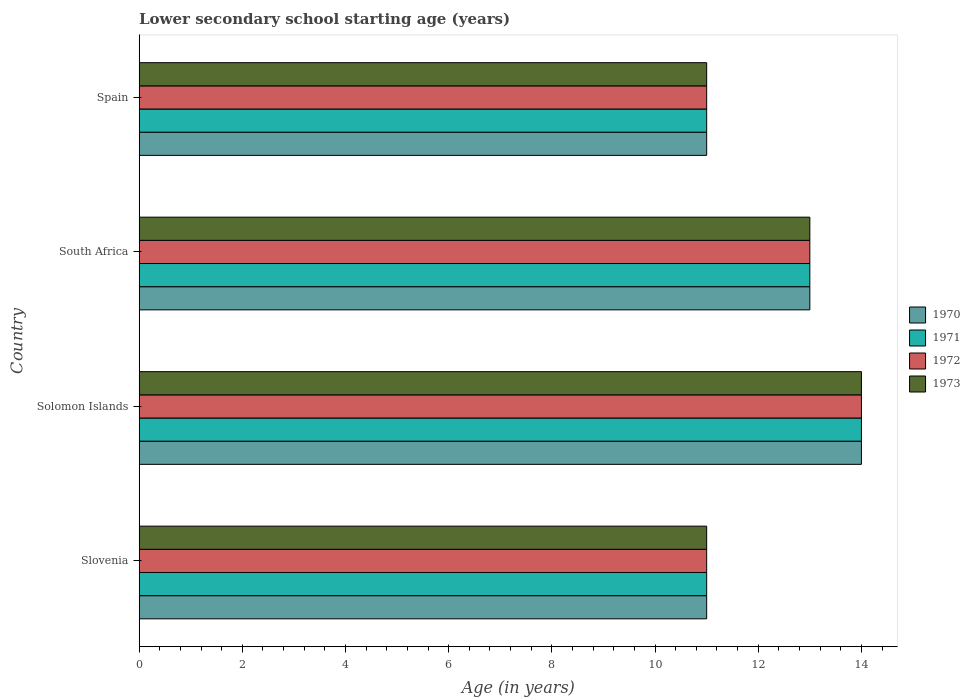How many different coloured bars are there?
Make the answer very short. 4. Are the number of bars per tick equal to the number of legend labels?
Keep it short and to the point. Yes. Are the number of bars on each tick of the Y-axis equal?
Keep it short and to the point. Yes. What is the label of the 1st group of bars from the top?
Give a very brief answer. Spain. What is the lower secondary school starting age of children in 1970 in Solomon Islands?
Provide a succinct answer. 14. Across all countries, what is the minimum lower secondary school starting age of children in 1973?
Make the answer very short. 11. In which country was the lower secondary school starting age of children in 1971 maximum?
Give a very brief answer. Solomon Islands. In which country was the lower secondary school starting age of children in 1973 minimum?
Your response must be concise. Slovenia. What is the total lower secondary school starting age of children in 1973 in the graph?
Offer a very short reply. 49. What is the difference between the lower secondary school starting age of children in 1972 in South Africa and that in Spain?
Ensure brevity in your answer.  2. What is the difference between the lower secondary school starting age of children in 1971 in Solomon Islands and the lower secondary school starting age of children in 1972 in Spain?
Your answer should be very brief. 3. What is the average lower secondary school starting age of children in 1970 per country?
Provide a short and direct response. 12.25. In how many countries, is the lower secondary school starting age of children in 1971 greater than 4 years?
Provide a short and direct response. 4. Is the lower secondary school starting age of children in 1972 in Slovenia less than that in South Africa?
Offer a terse response. Yes. Is the difference between the lower secondary school starting age of children in 1973 in Solomon Islands and South Africa greater than the difference between the lower secondary school starting age of children in 1971 in Solomon Islands and South Africa?
Ensure brevity in your answer.  No. What is the difference between the highest and the second highest lower secondary school starting age of children in 1973?
Give a very brief answer. 1. Is it the case that in every country, the sum of the lower secondary school starting age of children in 1971 and lower secondary school starting age of children in 1973 is greater than the lower secondary school starting age of children in 1972?
Provide a succinct answer. Yes. Does the graph contain any zero values?
Offer a very short reply. No. Does the graph contain grids?
Provide a short and direct response. No. Where does the legend appear in the graph?
Your answer should be very brief. Center right. How many legend labels are there?
Offer a terse response. 4. What is the title of the graph?
Your answer should be very brief. Lower secondary school starting age (years). What is the label or title of the X-axis?
Keep it short and to the point. Age (in years). What is the Age (in years) in 1973 in Slovenia?
Your response must be concise. 11. What is the Age (in years) in 1970 in Solomon Islands?
Provide a succinct answer. 14. What is the Age (in years) in 1971 in Solomon Islands?
Your response must be concise. 14. What is the Age (in years) of 1973 in Solomon Islands?
Your answer should be compact. 14. What is the Age (in years) in 1970 in South Africa?
Offer a very short reply. 13. What is the Age (in years) of 1972 in South Africa?
Offer a terse response. 13. What is the Age (in years) in 1973 in South Africa?
Offer a very short reply. 13. What is the Age (in years) in 1970 in Spain?
Provide a succinct answer. 11. What is the Age (in years) in 1971 in Spain?
Make the answer very short. 11. What is the Age (in years) in 1972 in Spain?
Make the answer very short. 11. Across all countries, what is the maximum Age (in years) of 1973?
Keep it short and to the point. 14. Across all countries, what is the minimum Age (in years) of 1972?
Provide a succinct answer. 11. What is the total Age (in years) in 1971 in the graph?
Your answer should be compact. 49. What is the total Age (in years) in 1973 in the graph?
Offer a terse response. 49. What is the difference between the Age (in years) in 1970 in Slovenia and that in Solomon Islands?
Offer a very short reply. -3. What is the difference between the Age (in years) of 1972 in Slovenia and that in Solomon Islands?
Your answer should be compact. -3. What is the difference between the Age (in years) of 1970 in Slovenia and that in South Africa?
Provide a short and direct response. -2. What is the difference between the Age (in years) in 1973 in Slovenia and that in South Africa?
Offer a terse response. -2. What is the difference between the Age (in years) in 1971 in Slovenia and that in Spain?
Offer a very short reply. 0. What is the difference between the Age (in years) in 1972 in Slovenia and that in Spain?
Give a very brief answer. 0. What is the difference between the Age (in years) of 1973 in Slovenia and that in Spain?
Ensure brevity in your answer.  0. What is the difference between the Age (in years) of 1970 in Solomon Islands and that in South Africa?
Offer a terse response. 1. What is the difference between the Age (in years) of 1971 in Solomon Islands and that in South Africa?
Offer a terse response. 1. What is the difference between the Age (in years) of 1972 in Solomon Islands and that in South Africa?
Provide a short and direct response. 1. What is the difference between the Age (in years) in 1973 in Solomon Islands and that in South Africa?
Offer a terse response. 1. What is the difference between the Age (in years) of 1970 in Solomon Islands and that in Spain?
Make the answer very short. 3. What is the difference between the Age (in years) in 1972 in Solomon Islands and that in Spain?
Ensure brevity in your answer.  3. What is the difference between the Age (in years) in 1973 in Solomon Islands and that in Spain?
Give a very brief answer. 3. What is the difference between the Age (in years) in 1972 in South Africa and that in Spain?
Keep it short and to the point. 2. What is the difference between the Age (in years) in 1970 in Slovenia and the Age (in years) in 1971 in Solomon Islands?
Your answer should be compact. -3. What is the difference between the Age (in years) of 1971 in Slovenia and the Age (in years) of 1972 in Solomon Islands?
Ensure brevity in your answer.  -3. What is the difference between the Age (in years) of 1970 in Slovenia and the Age (in years) of 1972 in South Africa?
Provide a succinct answer. -2. What is the difference between the Age (in years) of 1970 in Slovenia and the Age (in years) of 1973 in South Africa?
Your response must be concise. -2. What is the difference between the Age (in years) in 1971 in Slovenia and the Age (in years) in 1972 in South Africa?
Keep it short and to the point. -2. What is the difference between the Age (in years) in 1970 in Slovenia and the Age (in years) in 1972 in Spain?
Your answer should be very brief. 0. What is the difference between the Age (in years) in 1971 in Slovenia and the Age (in years) in 1973 in Spain?
Provide a succinct answer. 0. What is the difference between the Age (in years) of 1972 in Slovenia and the Age (in years) of 1973 in Spain?
Keep it short and to the point. 0. What is the difference between the Age (in years) of 1970 in Solomon Islands and the Age (in years) of 1971 in South Africa?
Your response must be concise. 1. What is the difference between the Age (in years) in 1970 in Solomon Islands and the Age (in years) in 1972 in South Africa?
Your answer should be very brief. 1. What is the difference between the Age (in years) of 1970 in Solomon Islands and the Age (in years) of 1973 in South Africa?
Offer a very short reply. 1. What is the difference between the Age (in years) in 1972 in Solomon Islands and the Age (in years) in 1973 in South Africa?
Offer a terse response. 1. What is the difference between the Age (in years) of 1970 in Solomon Islands and the Age (in years) of 1972 in Spain?
Your answer should be compact. 3. What is the difference between the Age (in years) of 1972 in Solomon Islands and the Age (in years) of 1973 in Spain?
Your answer should be compact. 3. What is the difference between the Age (in years) in 1970 in South Africa and the Age (in years) in 1971 in Spain?
Provide a succinct answer. 2. What is the difference between the Age (in years) in 1970 in South Africa and the Age (in years) in 1973 in Spain?
Provide a short and direct response. 2. What is the difference between the Age (in years) of 1971 in South Africa and the Age (in years) of 1972 in Spain?
Provide a short and direct response. 2. What is the difference between the Age (in years) of 1971 in South Africa and the Age (in years) of 1973 in Spain?
Provide a succinct answer. 2. What is the difference between the Age (in years) of 1972 in South Africa and the Age (in years) of 1973 in Spain?
Offer a terse response. 2. What is the average Age (in years) in 1970 per country?
Your response must be concise. 12.25. What is the average Age (in years) in 1971 per country?
Offer a terse response. 12.25. What is the average Age (in years) of 1972 per country?
Your answer should be compact. 12.25. What is the average Age (in years) in 1973 per country?
Give a very brief answer. 12.25. What is the difference between the Age (in years) of 1970 and Age (in years) of 1971 in Slovenia?
Offer a very short reply. 0. What is the difference between the Age (in years) of 1970 and Age (in years) of 1972 in Slovenia?
Your answer should be compact. 0. What is the difference between the Age (in years) of 1970 and Age (in years) of 1973 in Slovenia?
Provide a short and direct response. 0. What is the difference between the Age (in years) of 1971 and Age (in years) of 1973 in Slovenia?
Your response must be concise. 0. What is the difference between the Age (in years) in 1972 and Age (in years) in 1973 in Slovenia?
Provide a succinct answer. 0. What is the difference between the Age (in years) of 1970 and Age (in years) of 1971 in Solomon Islands?
Ensure brevity in your answer.  0. What is the difference between the Age (in years) in 1970 and Age (in years) in 1973 in Solomon Islands?
Offer a terse response. 0. What is the difference between the Age (in years) of 1971 and Age (in years) of 1973 in Solomon Islands?
Your response must be concise. 0. What is the difference between the Age (in years) of 1970 and Age (in years) of 1971 in Spain?
Offer a terse response. 0. What is the difference between the Age (in years) of 1970 and Age (in years) of 1972 in Spain?
Your answer should be compact. 0. What is the difference between the Age (in years) in 1971 and Age (in years) in 1973 in Spain?
Ensure brevity in your answer.  0. What is the ratio of the Age (in years) of 1970 in Slovenia to that in Solomon Islands?
Make the answer very short. 0.79. What is the ratio of the Age (in years) in 1971 in Slovenia to that in Solomon Islands?
Provide a succinct answer. 0.79. What is the ratio of the Age (in years) of 1972 in Slovenia to that in Solomon Islands?
Ensure brevity in your answer.  0.79. What is the ratio of the Age (in years) in 1973 in Slovenia to that in Solomon Islands?
Offer a very short reply. 0.79. What is the ratio of the Age (in years) in 1970 in Slovenia to that in South Africa?
Make the answer very short. 0.85. What is the ratio of the Age (in years) of 1971 in Slovenia to that in South Africa?
Give a very brief answer. 0.85. What is the ratio of the Age (in years) of 1972 in Slovenia to that in South Africa?
Give a very brief answer. 0.85. What is the ratio of the Age (in years) in 1973 in Slovenia to that in South Africa?
Give a very brief answer. 0.85. What is the ratio of the Age (in years) of 1970 in Slovenia to that in Spain?
Provide a succinct answer. 1. What is the ratio of the Age (in years) of 1971 in Slovenia to that in Spain?
Your response must be concise. 1. What is the ratio of the Age (in years) in 1972 in Slovenia to that in Spain?
Keep it short and to the point. 1. What is the ratio of the Age (in years) in 1973 in Slovenia to that in Spain?
Your response must be concise. 1. What is the ratio of the Age (in years) of 1971 in Solomon Islands to that in South Africa?
Offer a very short reply. 1.08. What is the ratio of the Age (in years) of 1970 in Solomon Islands to that in Spain?
Ensure brevity in your answer.  1.27. What is the ratio of the Age (in years) in 1971 in Solomon Islands to that in Spain?
Offer a very short reply. 1.27. What is the ratio of the Age (in years) in 1972 in Solomon Islands to that in Spain?
Your answer should be compact. 1.27. What is the ratio of the Age (in years) in 1973 in Solomon Islands to that in Spain?
Your answer should be very brief. 1.27. What is the ratio of the Age (in years) in 1970 in South Africa to that in Spain?
Make the answer very short. 1.18. What is the ratio of the Age (in years) in 1971 in South Africa to that in Spain?
Your answer should be very brief. 1.18. What is the ratio of the Age (in years) in 1972 in South Africa to that in Spain?
Offer a very short reply. 1.18. What is the ratio of the Age (in years) in 1973 in South Africa to that in Spain?
Provide a short and direct response. 1.18. What is the difference between the highest and the lowest Age (in years) in 1970?
Provide a succinct answer. 3. What is the difference between the highest and the lowest Age (in years) in 1971?
Provide a short and direct response. 3. What is the difference between the highest and the lowest Age (in years) in 1972?
Your response must be concise. 3. 